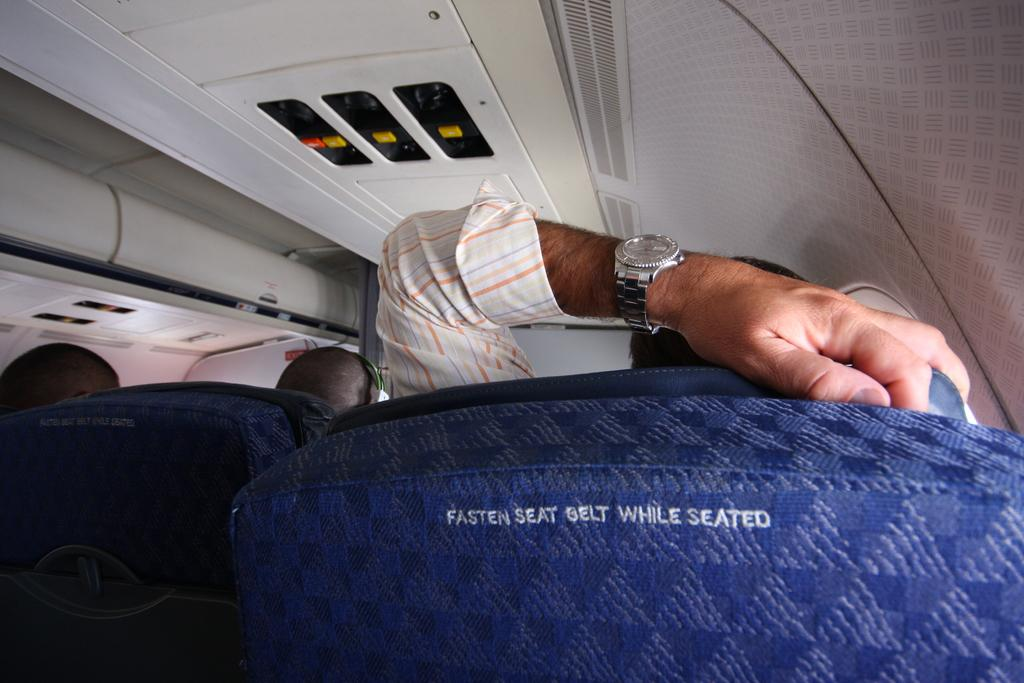<image>
Write a terse but informative summary of the picture. A blue airplane seat with the words "Fasten Seat belt While Seated" on the back 